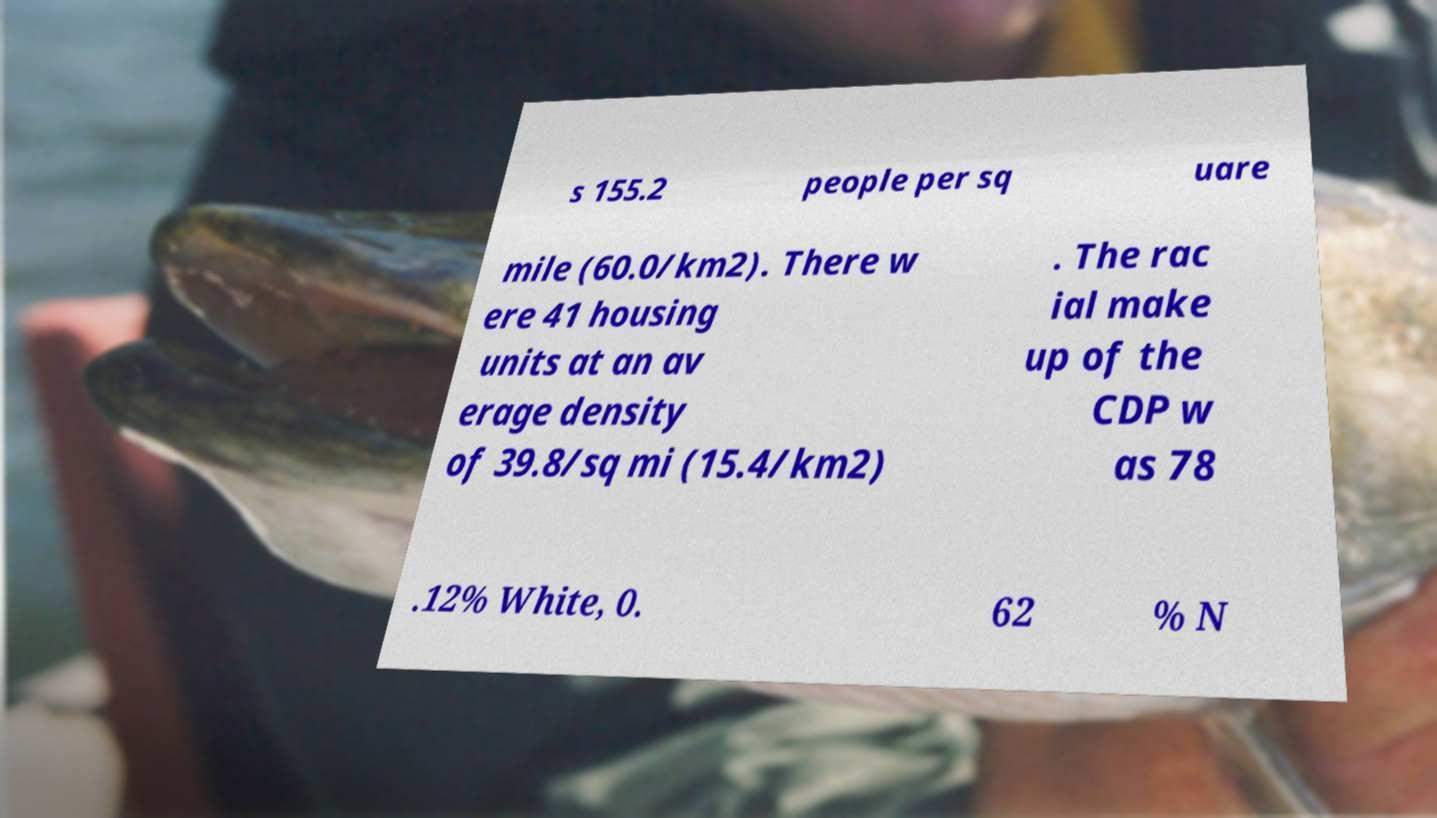Please identify and transcribe the text found in this image. s 155.2 people per sq uare mile (60.0/km2). There w ere 41 housing units at an av erage density of 39.8/sq mi (15.4/km2) . The rac ial make up of the CDP w as 78 .12% White, 0. 62 % N 